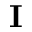Convert formula to latex. <formula><loc_0><loc_0><loc_500><loc_500>I</formula> 